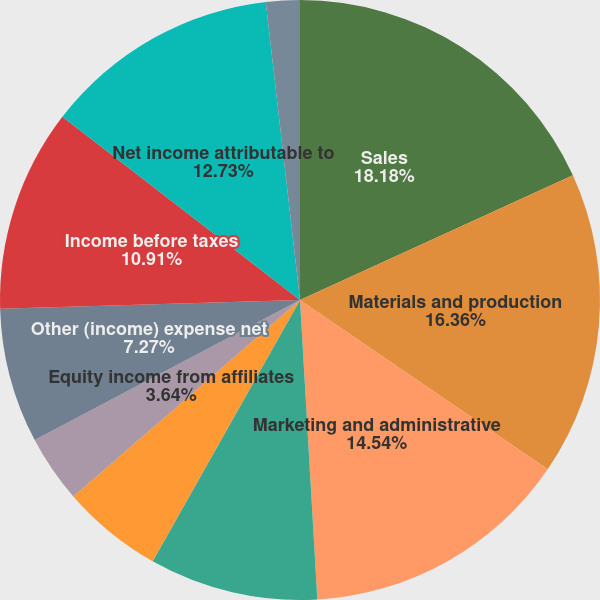<chart> <loc_0><loc_0><loc_500><loc_500><pie_chart><fcel>Sales<fcel>Materials and production<fcel>Marketing and administrative<fcel>Research and development<fcel>Restructuring costs<fcel>Equity income from affiliates<fcel>Other (income) expense net<fcel>Income before taxes<fcel>Net income attributable to<fcel>Basic earnings per common<nl><fcel>18.18%<fcel>16.36%<fcel>14.54%<fcel>9.09%<fcel>5.46%<fcel>3.64%<fcel>7.27%<fcel>10.91%<fcel>12.73%<fcel>1.82%<nl></chart> 